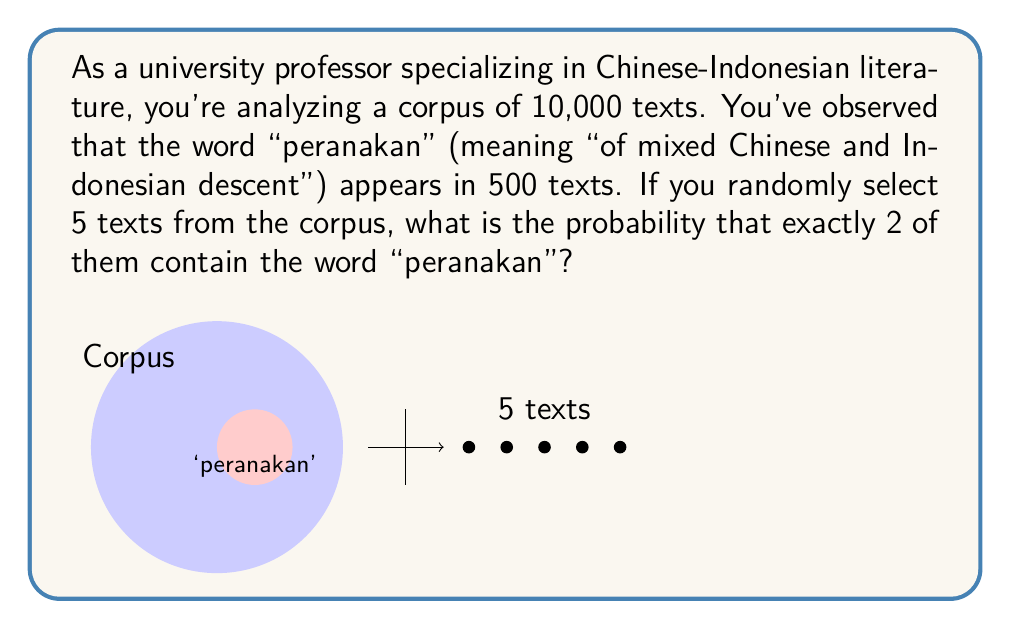What is the answer to this math problem? To solve this problem, we can use the binomial probability formula:

$$P(X = k) = \binom{n}{k} p^k (1-p)^{n-k}$$

Where:
- $n$ is the number of trials (texts selected)
- $k$ is the number of successes (texts containing "peranakan")
- $p$ is the probability of success on a single trial

Step 1: Calculate $p$
$p = \frac{\text{texts with "peranakan"}}{\text{total texts}} = \frac{500}{10000} = 0.05$

Step 2: Identify $n$ and $k$
$n = 5$ (selecting 5 texts)
$k = 2$ (exactly 2 texts containing "peranakan")

Step 3: Calculate $\binom{n}{k}$
$$\binom{5}{2} = \frac{5!}{2!(5-2)!} = \frac{5 \cdot 4}{2 \cdot 1} = 10$$

Step 4: Apply the binomial probability formula
$$P(X = 2) = \binom{5}{2} (0.05)^2 (1-0.05)^{5-2}$$
$$= 10 \cdot (0.05)^2 \cdot (0.95)^3$$
$$= 10 \cdot 0.0025 \cdot 0.857375$$
$$= 0.021434375$$

Step 5: Convert to percentage
$0.021434375 \cdot 100\% = 2.1434375\%$
Answer: 2.14% (rounded to two decimal places) 